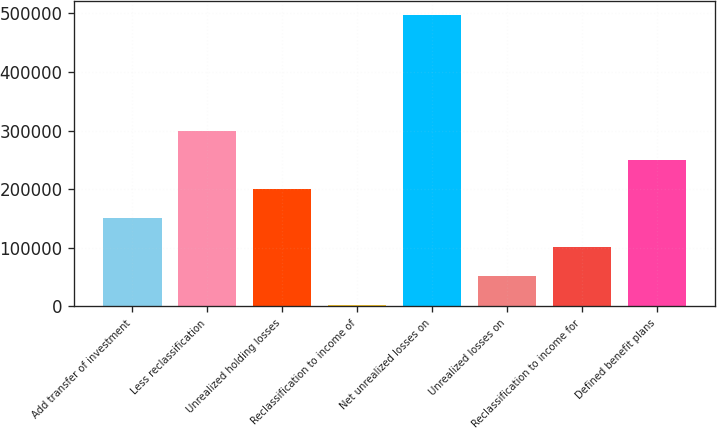Convert chart to OTSL. <chart><loc_0><loc_0><loc_500><loc_500><bar_chart><fcel>Add transfer of investment<fcel>Less reclassification<fcel>Unrealized holding losses<fcel>Reclassification to income of<fcel>Net unrealized losses on<fcel>Unrealized losses on<fcel>Reclassification to income for<fcel>Defined benefit plans<nl><fcel>151477<fcel>299670<fcel>200875<fcel>3283<fcel>497262<fcel>52680.9<fcel>102079<fcel>250272<nl></chart> 